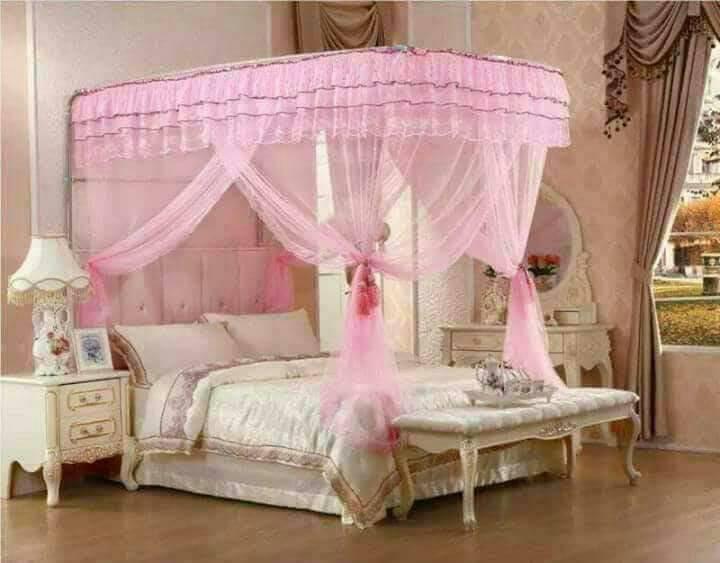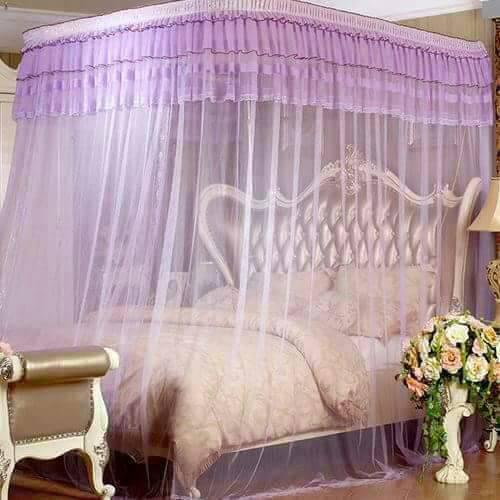The first image is the image on the left, the second image is the image on the right. Examine the images to the left and right. Is the description "The bed in one of the images is surrounded by purple netting" accurate? Answer yes or no. Yes. The first image is the image on the left, the second image is the image on the right. For the images shown, is this caption "All bed canopies are the same shape as the bed with a deep ruffle at the top and sheer curtains draping down." true? Answer yes or no. Yes. 